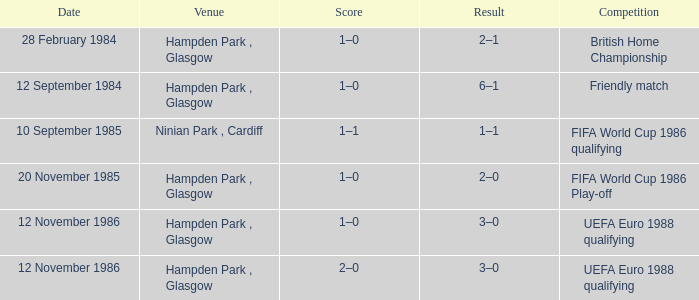What is the Score of the Fifa World Cup 1986 Play-off Competition? 1–0. 